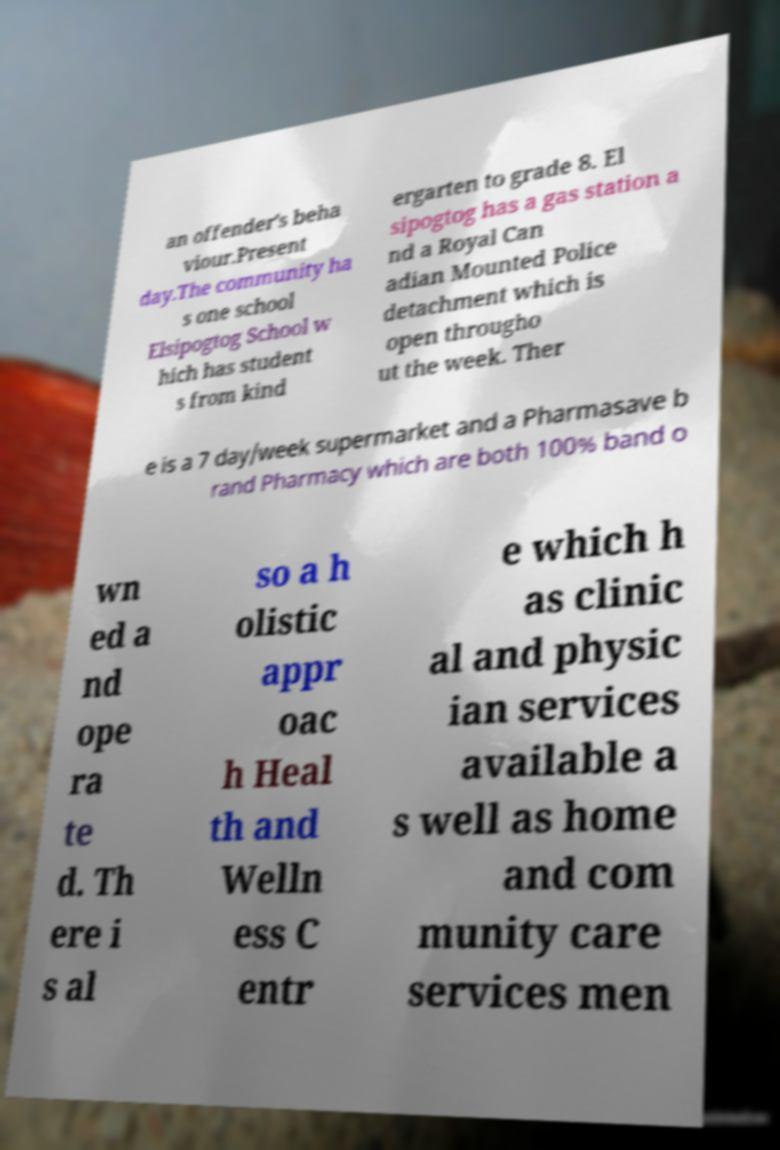Could you assist in decoding the text presented in this image and type it out clearly? an offender's beha viour.Present day.The community ha s one school Elsipogtog School w hich has student s from kind ergarten to grade 8. El sipogtog has a gas station a nd a Royal Can adian Mounted Police detachment which is open througho ut the week. Ther e is a 7 day/week supermarket and a Pharmasave b rand Pharmacy which are both 100% band o wn ed a nd ope ra te d. Th ere i s al so a h olistic appr oac h Heal th and Welln ess C entr e which h as clinic al and physic ian services available a s well as home and com munity care services men 